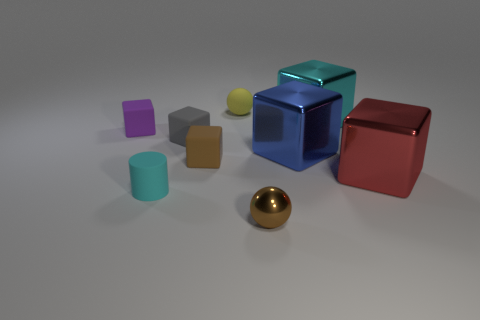Subtract 1 cubes. How many cubes are left? 5 Subtract all large blue metal cubes. How many cubes are left? 5 Subtract all cyan cubes. How many cubes are left? 5 Subtract all gray cubes. Subtract all gray spheres. How many cubes are left? 5 Subtract all cubes. How many objects are left? 3 Add 1 big shiny cubes. How many big shiny cubes exist? 4 Subtract 0 blue spheres. How many objects are left? 9 Subtract all large cyan metallic spheres. Subtract all cyan matte things. How many objects are left? 8 Add 4 tiny cylinders. How many tiny cylinders are left? 5 